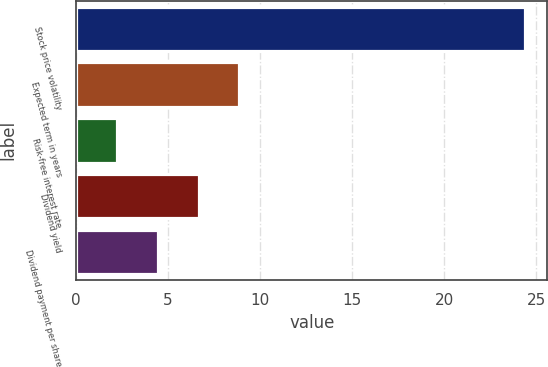Convert chart to OTSL. <chart><loc_0><loc_0><loc_500><loc_500><bar_chart><fcel>Stock price volatility<fcel>Expected term in years<fcel>Risk-free interest rate<fcel>Dividend yield<fcel>Dividend payment per share<nl><fcel>24.39<fcel>8.88<fcel>2.22<fcel>6.66<fcel>4.44<nl></chart> 